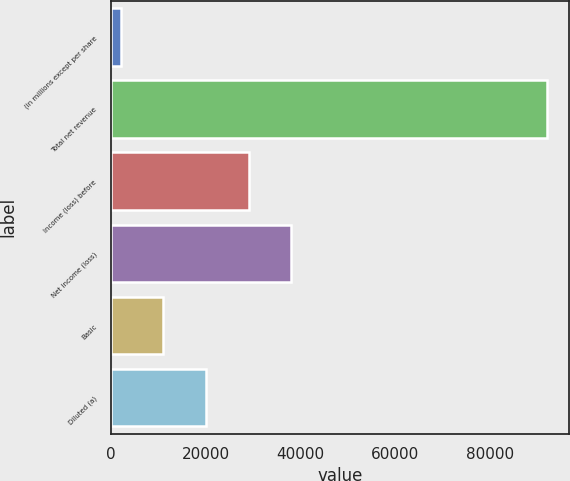Convert chart to OTSL. <chart><loc_0><loc_0><loc_500><loc_500><bar_chart><fcel>(in millions except per share<fcel>Total net revenue<fcel>Income (loss) before<fcel>Net income (loss)<fcel>Basic<fcel>Diluted (a)<nl><fcel>2007<fcel>92052<fcel>29020.5<fcel>38025<fcel>11011.5<fcel>20016<nl></chart> 